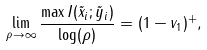<formula> <loc_0><loc_0><loc_500><loc_500>\lim _ { \rho \rightarrow \infty } \frac { \max I ( \tilde { x } _ { i } ; \tilde { y } _ { i } ) } { \log ( \rho ) } & = ( 1 - v _ { 1 } ) ^ { + } ,</formula> 